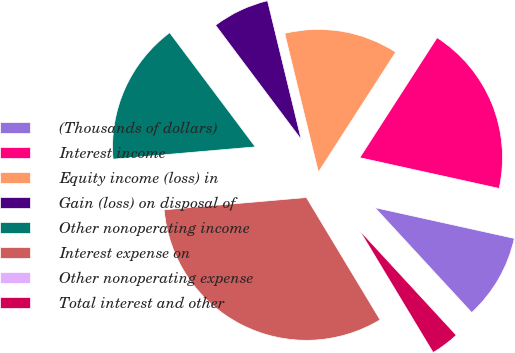Convert chart to OTSL. <chart><loc_0><loc_0><loc_500><loc_500><pie_chart><fcel>(Thousands of dollars)<fcel>Interest income<fcel>Equity income (loss) in<fcel>Gain (loss) on disposal of<fcel>Other nonoperating income<fcel>Interest expense on<fcel>Other nonoperating expense<fcel>Total interest and other<nl><fcel>9.68%<fcel>19.35%<fcel>12.9%<fcel>6.45%<fcel>16.13%<fcel>32.26%<fcel>0.0%<fcel>3.23%<nl></chart> 